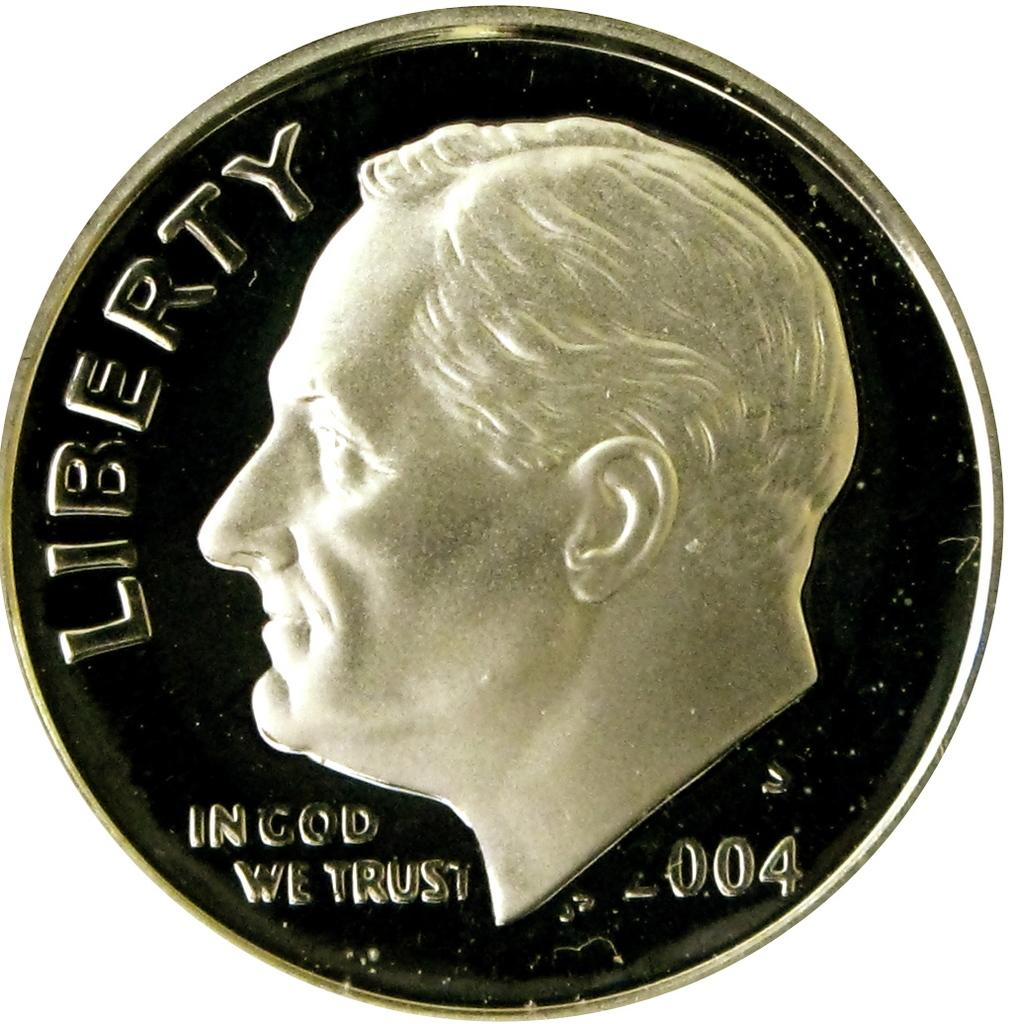<image>
Write a terse but informative summary of the picture. A coin that says Liberty and In God We Trust 2004. 